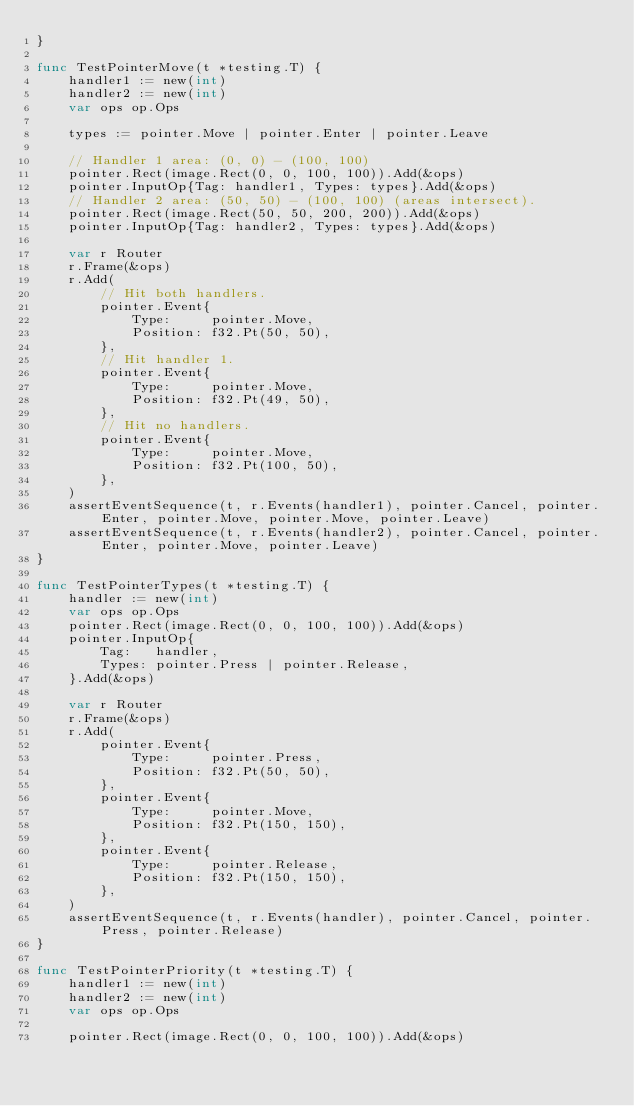Convert code to text. <code><loc_0><loc_0><loc_500><loc_500><_Go_>}

func TestPointerMove(t *testing.T) {
	handler1 := new(int)
	handler2 := new(int)
	var ops op.Ops

	types := pointer.Move | pointer.Enter | pointer.Leave

	// Handler 1 area: (0, 0) - (100, 100)
	pointer.Rect(image.Rect(0, 0, 100, 100)).Add(&ops)
	pointer.InputOp{Tag: handler1, Types: types}.Add(&ops)
	// Handler 2 area: (50, 50) - (100, 100) (areas intersect).
	pointer.Rect(image.Rect(50, 50, 200, 200)).Add(&ops)
	pointer.InputOp{Tag: handler2, Types: types}.Add(&ops)

	var r Router
	r.Frame(&ops)
	r.Add(
		// Hit both handlers.
		pointer.Event{
			Type:     pointer.Move,
			Position: f32.Pt(50, 50),
		},
		// Hit handler 1.
		pointer.Event{
			Type:     pointer.Move,
			Position: f32.Pt(49, 50),
		},
		// Hit no handlers.
		pointer.Event{
			Type:     pointer.Move,
			Position: f32.Pt(100, 50),
		},
	)
	assertEventSequence(t, r.Events(handler1), pointer.Cancel, pointer.Enter, pointer.Move, pointer.Move, pointer.Leave)
	assertEventSequence(t, r.Events(handler2), pointer.Cancel, pointer.Enter, pointer.Move, pointer.Leave)
}

func TestPointerTypes(t *testing.T) {
	handler := new(int)
	var ops op.Ops
	pointer.Rect(image.Rect(0, 0, 100, 100)).Add(&ops)
	pointer.InputOp{
		Tag:   handler,
		Types: pointer.Press | pointer.Release,
	}.Add(&ops)

	var r Router
	r.Frame(&ops)
	r.Add(
		pointer.Event{
			Type:     pointer.Press,
			Position: f32.Pt(50, 50),
		},
		pointer.Event{
			Type:     pointer.Move,
			Position: f32.Pt(150, 150),
		},
		pointer.Event{
			Type:     pointer.Release,
			Position: f32.Pt(150, 150),
		},
	)
	assertEventSequence(t, r.Events(handler), pointer.Cancel, pointer.Press, pointer.Release)
}

func TestPointerPriority(t *testing.T) {
	handler1 := new(int)
	handler2 := new(int)
	var ops op.Ops

	pointer.Rect(image.Rect(0, 0, 100, 100)).Add(&ops)</code> 